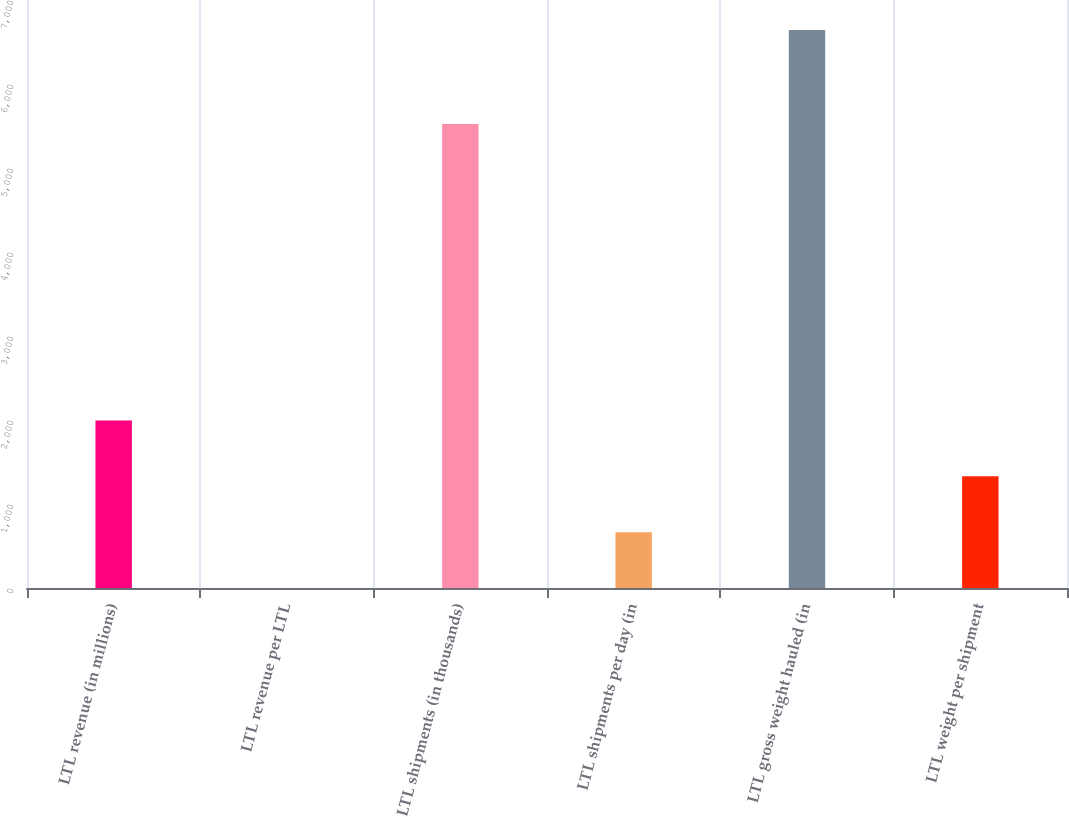Convert chart. <chart><loc_0><loc_0><loc_500><loc_500><bar_chart><fcel>LTL revenue (in millions)<fcel>LTL revenue per LTL<fcel>LTL shipments (in thousands)<fcel>LTL shipments per day (in<fcel>LTL gross weight hauled (in<fcel>LTL weight per shipment<nl><fcel>1993.18<fcel>0.4<fcel>5525<fcel>664.66<fcel>6643<fcel>1328.92<nl></chart> 